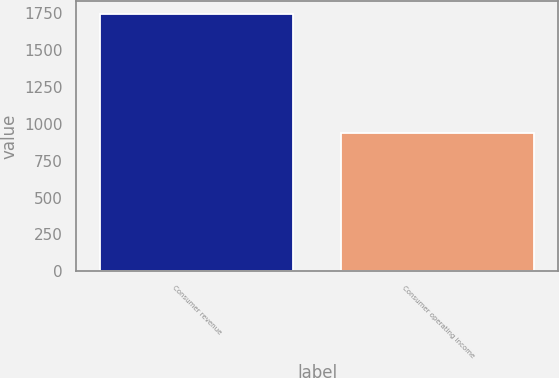Convert chart to OTSL. <chart><loc_0><loc_0><loc_500><loc_500><bar_chart><fcel>Consumer revenue<fcel>Consumer operating income<nl><fcel>1746<fcel>939<nl></chart> 